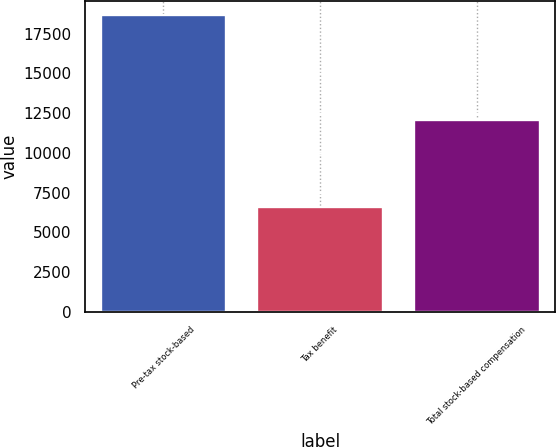Convert chart. <chart><loc_0><loc_0><loc_500><loc_500><bar_chart><fcel>Pre-tax stock-based<fcel>Tax benefit<fcel>Total stock-based compensation<nl><fcel>18650<fcel>6579<fcel>12071<nl></chart> 